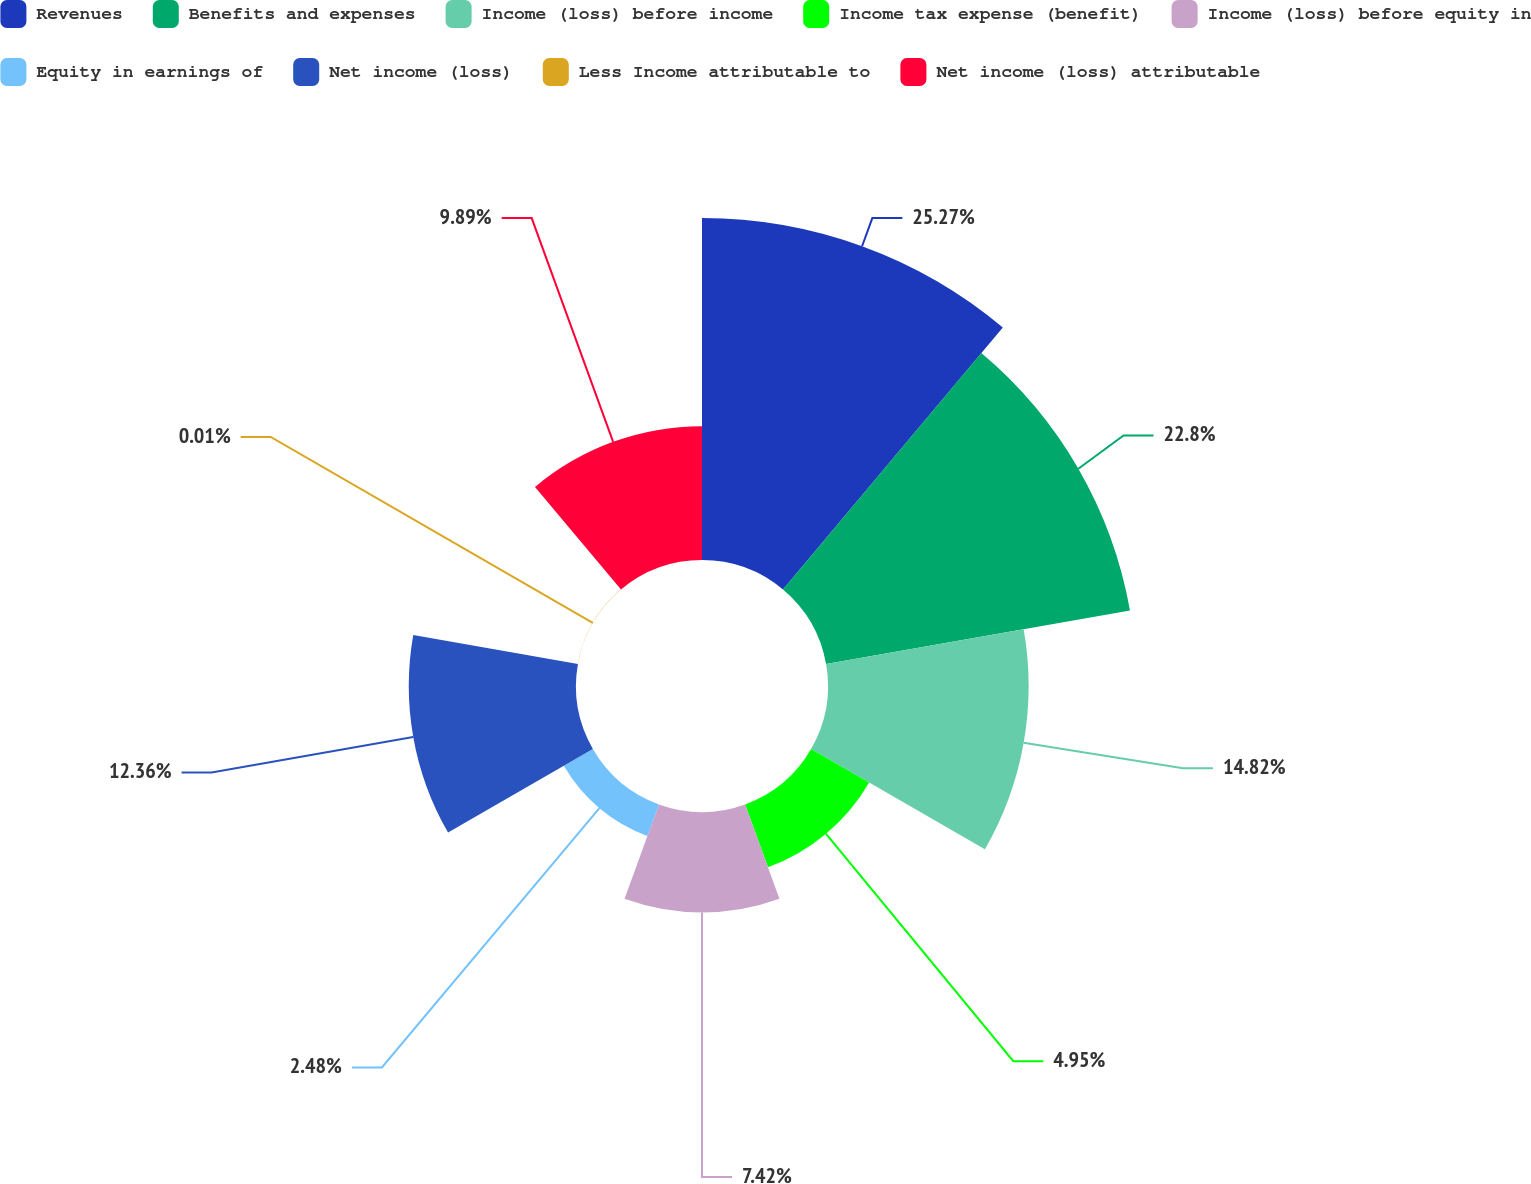<chart> <loc_0><loc_0><loc_500><loc_500><pie_chart><fcel>Revenues<fcel>Benefits and expenses<fcel>Income (loss) before income<fcel>Income tax expense (benefit)<fcel>Income (loss) before equity in<fcel>Equity in earnings of<fcel>Net income (loss)<fcel>Less Income attributable to<fcel>Net income (loss) attributable<nl><fcel>25.28%<fcel>22.81%<fcel>14.83%<fcel>4.95%<fcel>7.42%<fcel>2.48%<fcel>12.36%<fcel>0.01%<fcel>9.89%<nl></chart> 